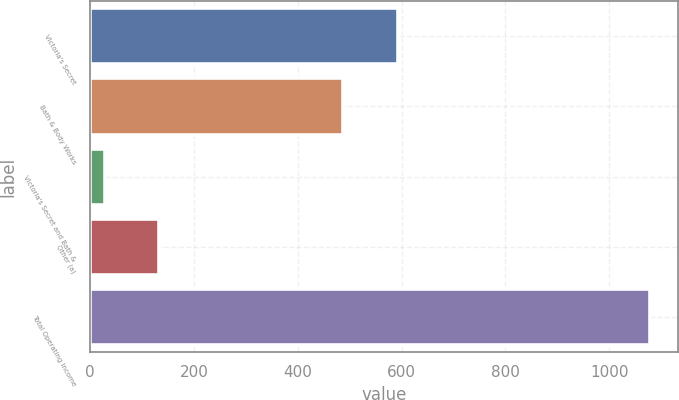Convert chart to OTSL. <chart><loc_0><loc_0><loc_500><loc_500><bar_chart><fcel>Victoria's Secret<fcel>Bath & Body Works<fcel>Victoria's Secret and Bath &<fcel>Other (a)<fcel>Total Operating Income<nl><fcel>594<fcel>487<fcel>28<fcel>133<fcel>1078<nl></chart> 